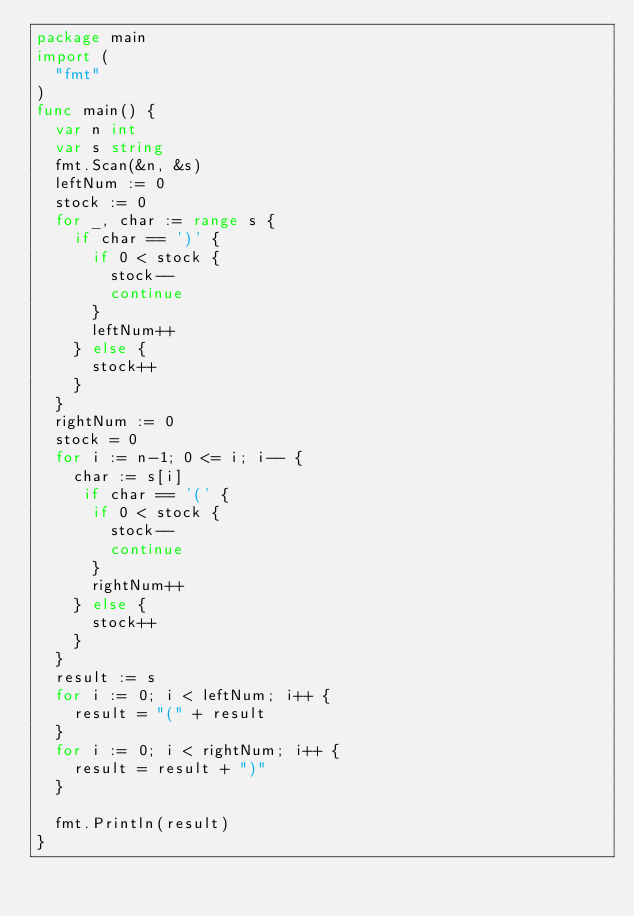Convert code to text. <code><loc_0><loc_0><loc_500><loc_500><_Go_>package main
import (
  "fmt"
)
func main() {
  var n int
  var s string
  fmt.Scan(&n, &s)
  leftNum := 0
  stock := 0
  for _, char := range s {
    if char == ')' {
      if 0 < stock {
        stock--
        continue
      }
      leftNum++
    } else {
      stock++
    }
  }
  rightNum := 0
  stock = 0
  for i := n-1; 0 <= i; i-- {
    char := s[i]
     if char == '(' {
      if 0 < stock {
        stock--
        continue
      }
      rightNum++
    } else {
      stock++
    }
  }
  result := s
  for i := 0; i < leftNum; i++ {
    result = "(" + result
  }
  for i := 0; i < rightNum; i++ {
    result = result + ")"
  }
  
  fmt.Println(result)
}</code> 